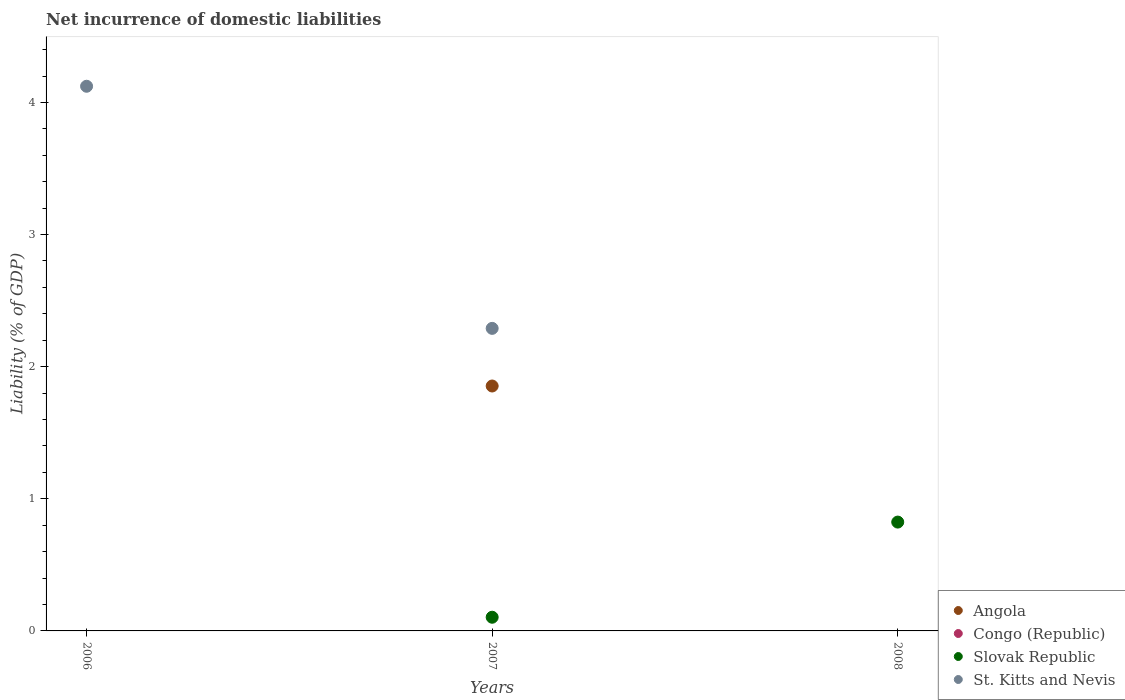Is the number of dotlines equal to the number of legend labels?
Offer a terse response. No. What is the net incurrence of domestic liabilities in Congo (Republic) in 2008?
Offer a very short reply. 0. Across all years, what is the maximum net incurrence of domestic liabilities in Angola?
Make the answer very short. 1.85. What is the total net incurrence of domestic liabilities in St. Kitts and Nevis in the graph?
Keep it short and to the point. 6.41. What is the difference between the net incurrence of domestic liabilities in Slovak Republic in 2007 and that in 2008?
Your answer should be very brief. -0.72. What is the difference between the net incurrence of domestic liabilities in Slovak Republic in 2008 and the net incurrence of domestic liabilities in St. Kitts and Nevis in 2007?
Provide a succinct answer. -1.47. What is the average net incurrence of domestic liabilities in St. Kitts and Nevis per year?
Offer a terse response. 2.14. In the year 2007, what is the difference between the net incurrence of domestic liabilities in Angola and net incurrence of domestic liabilities in St. Kitts and Nevis?
Offer a very short reply. -0.44. What is the ratio of the net incurrence of domestic liabilities in St. Kitts and Nevis in 2006 to that in 2007?
Give a very brief answer. 1.8. What is the difference between the highest and the lowest net incurrence of domestic liabilities in Slovak Republic?
Your answer should be compact. 0.82. In how many years, is the net incurrence of domestic liabilities in Slovak Republic greater than the average net incurrence of domestic liabilities in Slovak Republic taken over all years?
Your response must be concise. 1. Is it the case that in every year, the sum of the net incurrence of domestic liabilities in Congo (Republic) and net incurrence of domestic liabilities in Slovak Republic  is greater than the sum of net incurrence of domestic liabilities in St. Kitts and Nevis and net incurrence of domestic liabilities in Angola?
Provide a succinct answer. No. Does the net incurrence of domestic liabilities in St. Kitts and Nevis monotonically increase over the years?
Make the answer very short. No. Is the net incurrence of domestic liabilities in St. Kitts and Nevis strictly greater than the net incurrence of domestic liabilities in Angola over the years?
Your answer should be compact. No. How many dotlines are there?
Keep it short and to the point. 3. How many years are there in the graph?
Offer a very short reply. 3. Are the values on the major ticks of Y-axis written in scientific E-notation?
Your response must be concise. No. Does the graph contain any zero values?
Make the answer very short. Yes. Does the graph contain grids?
Your response must be concise. No. How are the legend labels stacked?
Your answer should be compact. Vertical. What is the title of the graph?
Keep it short and to the point. Net incurrence of domestic liabilities. What is the label or title of the X-axis?
Make the answer very short. Years. What is the label or title of the Y-axis?
Keep it short and to the point. Liability (% of GDP). What is the Liability (% of GDP) in Slovak Republic in 2006?
Give a very brief answer. 0. What is the Liability (% of GDP) of St. Kitts and Nevis in 2006?
Offer a very short reply. 4.12. What is the Liability (% of GDP) of Angola in 2007?
Give a very brief answer. 1.85. What is the Liability (% of GDP) of Slovak Republic in 2007?
Your response must be concise. 0.1. What is the Liability (% of GDP) of St. Kitts and Nevis in 2007?
Your answer should be compact. 2.29. What is the Liability (% of GDP) in Angola in 2008?
Your answer should be compact. 0. What is the Liability (% of GDP) of Congo (Republic) in 2008?
Offer a very short reply. 0. What is the Liability (% of GDP) of Slovak Republic in 2008?
Keep it short and to the point. 0.82. Across all years, what is the maximum Liability (% of GDP) of Angola?
Offer a very short reply. 1.85. Across all years, what is the maximum Liability (% of GDP) in Slovak Republic?
Provide a succinct answer. 0.82. Across all years, what is the maximum Liability (% of GDP) of St. Kitts and Nevis?
Your answer should be compact. 4.12. Across all years, what is the minimum Liability (% of GDP) in Angola?
Offer a terse response. 0. Across all years, what is the minimum Liability (% of GDP) of St. Kitts and Nevis?
Give a very brief answer. 0. What is the total Liability (% of GDP) of Angola in the graph?
Your answer should be compact. 1.85. What is the total Liability (% of GDP) of Congo (Republic) in the graph?
Provide a succinct answer. 0. What is the total Liability (% of GDP) in Slovak Republic in the graph?
Your answer should be compact. 0.93. What is the total Liability (% of GDP) in St. Kitts and Nevis in the graph?
Give a very brief answer. 6.41. What is the difference between the Liability (% of GDP) of St. Kitts and Nevis in 2006 and that in 2007?
Your answer should be compact. 1.83. What is the difference between the Liability (% of GDP) of Slovak Republic in 2007 and that in 2008?
Your answer should be very brief. -0.72. What is the average Liability (% of GDP) of Angola per year?
Keep it short and to the point. 0.62. What is the average Liability (% of GDP) of Congo (Republic) per year?
Your response must be concise. 0. What is the average Liability (% of GDP) in Slovak Republic per year?
Keep it short and to the point. 0.31. What is the average Liability (% of GDP) in St. Kitts and Nevis per year?
Make the answer very short. 2.14. In the year 2007, what is the difference between the Liability (% of GDP) in Angola and Liability (% of GDP) in Slovak Republic?
Offer a very short reply. 1.75. In the year 2007, what is the difference between the Liability (% of GDP) of Angola and Liability (% of GDP) of St. Kitts and Nevis?
Offer a terse response. -0.44. In the year 2007, what is the difference between the Liability (% of GDP) of Slovak Republic and Liability (% of GDP) of St. Kitts and Nevis?
Make the answer very short. -2.19. What is the ratio of the Liability (% of GDP) of St. Kitts and Nevis in 2006 to that in 2007?
Offer a terse response. 1.8. What is the ratio of the Liability (% of GDP) in Slovak Republic in 2007 to that in 2008?
Offer a very short reply. 0.13. What is the difference between the highest and the lowest Liability (% of GDP) in Angola?
Offer a very short reply. 1.85. What is the difference between the highest and the lowest Liability (% of GDP) of Slovak Republic?
Provide a succinct answer. 0.82. What is the difference between the highest and the lowest Liability (% of GDP) of St. Kitts and Nevis?
Your answer should be very brief. 4.12. 